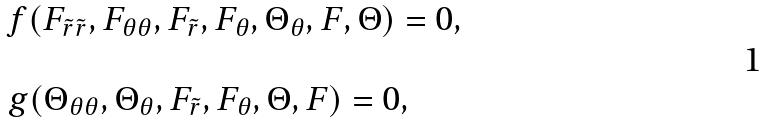<formula> <loc_0><loc_0><loc_500><loc_500>\begin{array} { l } f ( F _ { \tilde { r } \tilde { r } } , F _ { \theta \theta } , F _ { \tilde { r } } , F _ { \theta } , \Theta _ { \theta } , F , \Theta ) = 0 , \\ \quad \\ g ( \Theta _ { \theta \theta } , \Theta _ { \theta } , F _ { \tilde { r } } , F _ { \theta } , \Theta , F ) = 0 , \end{array}</formula> 